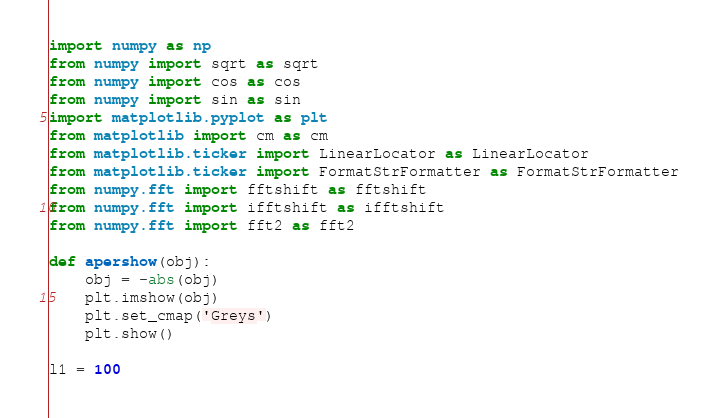<code> <loc_0><loc_0><loc_500><loc_500><_Python_>import numpy as np
from numpy import sqrt as sqrt
from numpy import cos as cos
from numpy import sin as sin
import matplotlib.pyplot as plt
from matplotlib import cm as cm
from matplotlib.ticker import LinearLocator as LinearLocator
from matplotlib.ticker import FormatStrFormatter as FormatStrFormatter
from numpy.fft import fftshift as fftshift
from numpy.fft import ifftshift as ifftshift
from numpy.fft import fft2 as fft2

def apershow(obj):
	obj = -abs(obj)
	plt.imshow(obj)
	plt.set_cmap('Greys')
	plt.show()

l1 = 100</code> 